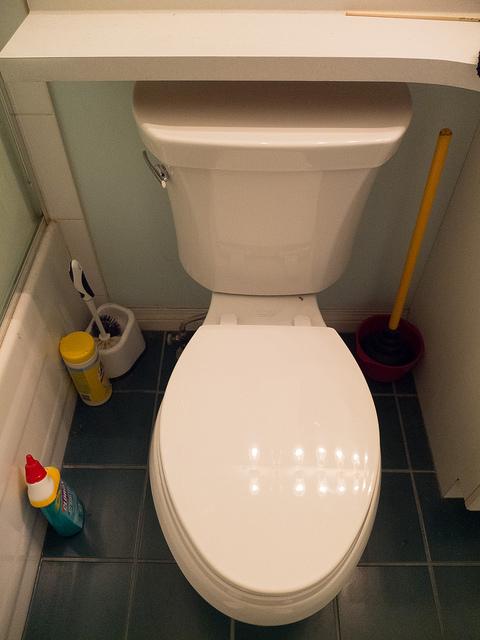Do you a toilet cleaner?
Answer briefly. Yes. What room is shown?
Quick response, please. Bathroom. Is this toilet clean?
Short answer required. Yes. 